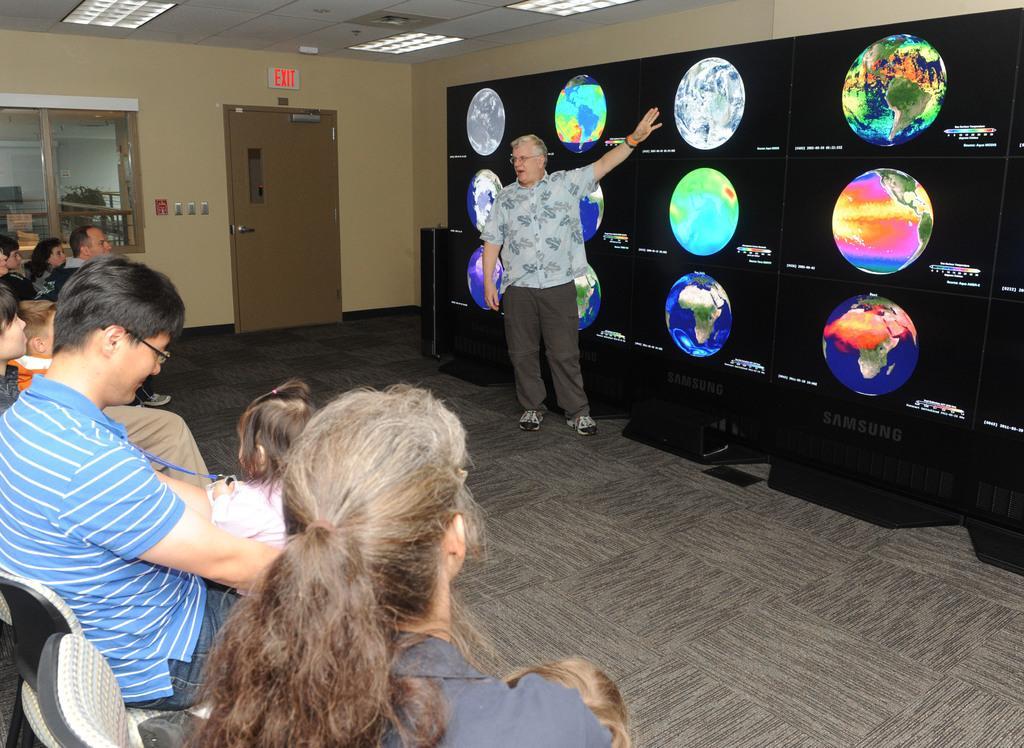How would you summarize this image in a sentence or two? In this image on the left side there are a group of people who are sitting on chairs, and in the center there is one man who is standing and beside him there is a television and it seems that he is talking something. In the background there is a door, wall and a glass window. On the top there is ceiling and some lights, at the bottom there is a floor. 